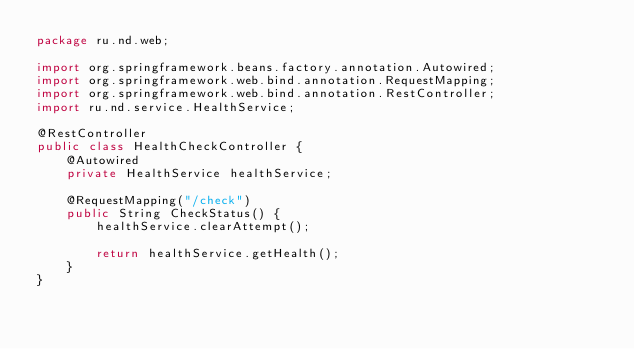<code> <loc_0><loc_0><loc_500><loc_500><_Java_>package ru.nd.web;

import org.springframework.beans.factory.annotation.Autowired;
import org.springframework.web.bind.annotation.RequestMapping;
import org.springframework.web.bind.annotation.RestController;
import ru.nd.service.HealthService;

@RestController
public class HealthCheckController {
    @Autowired
    private HealthService healthService;

    @RequestMapping("/check")
    public String CheckStatus() {
        healthService.clearAttempt();

        return healthService.getHealth();
    }
}
</code> 